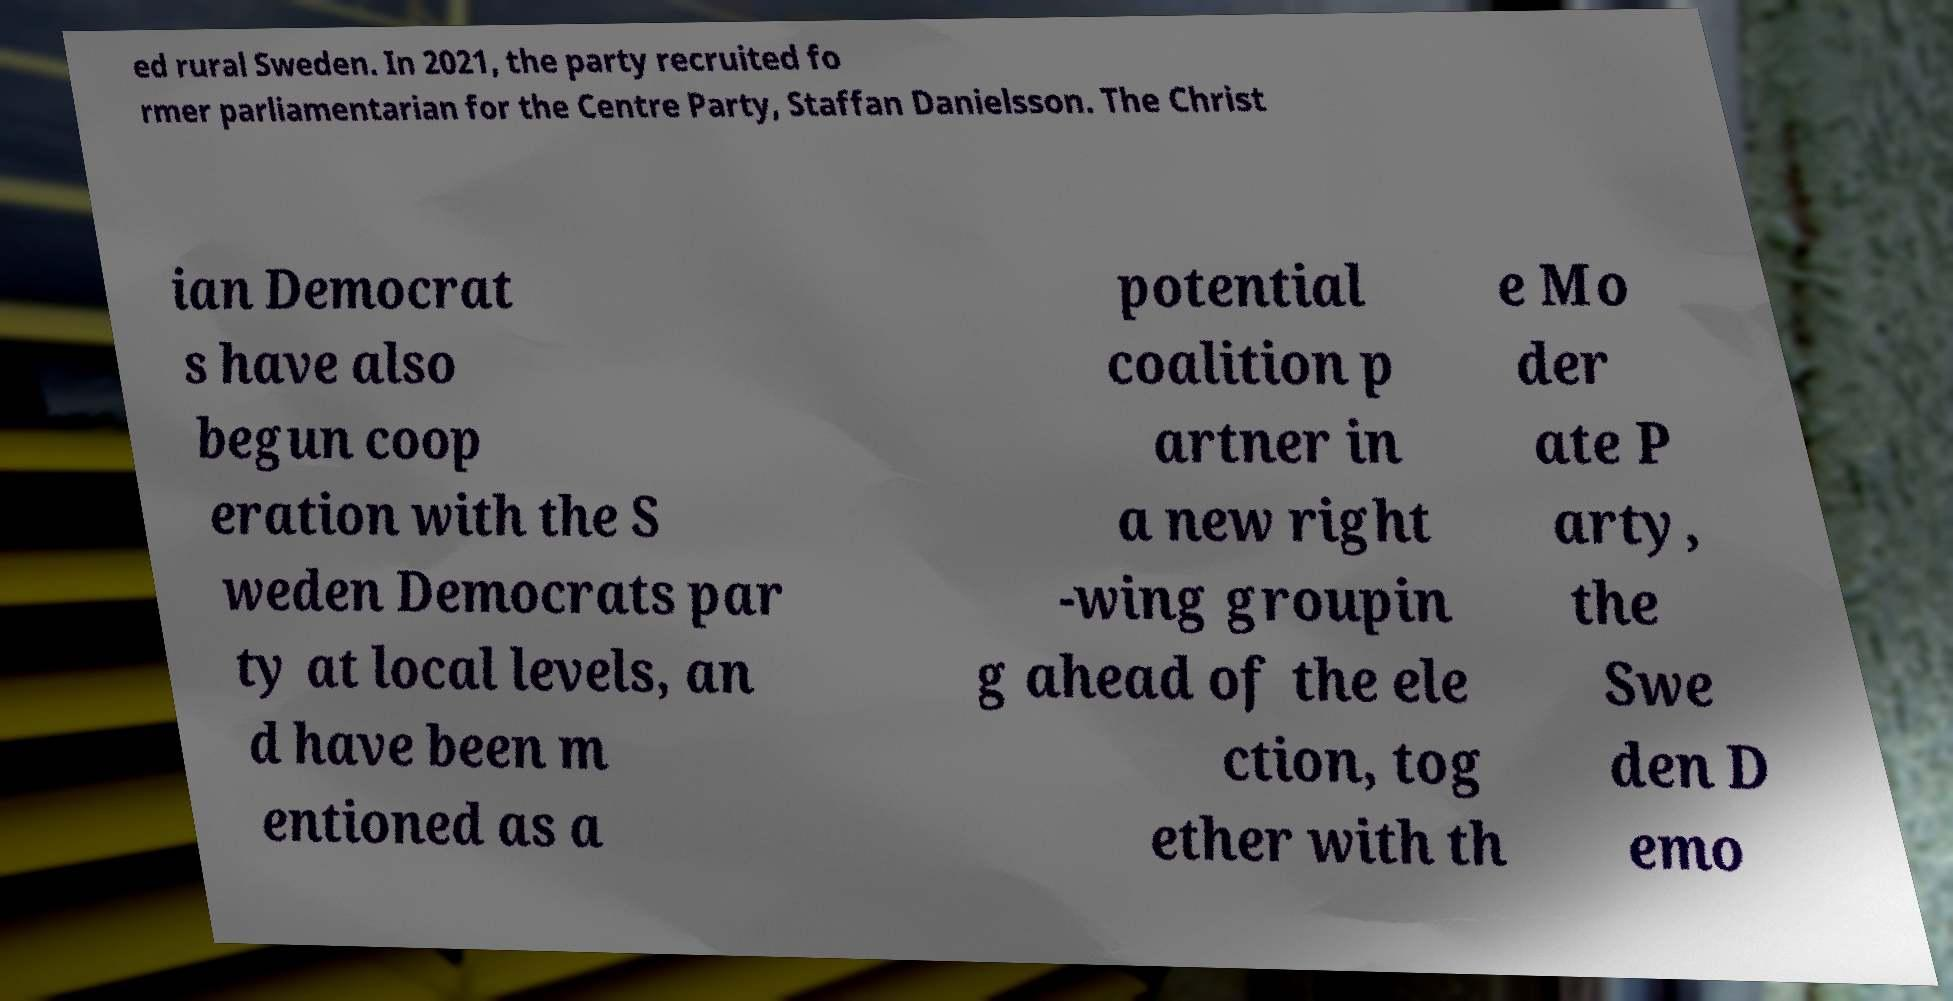Can you accurately transcribe the text from the provided image for me? ed rural Sweden. In 2021, the party recruited fo rmer parliamentarian for the Centre Party, Staffan Danielsson. The Christ ian Democrat s have also begun coop eration with the S weden Democrats par ty at local levels, an d have been m entioned as a potential coalition p artner in a new right -wing groupin g ahead of the ele ction, tog ether with th e Mo der ate P arty, the Swe den D emo 